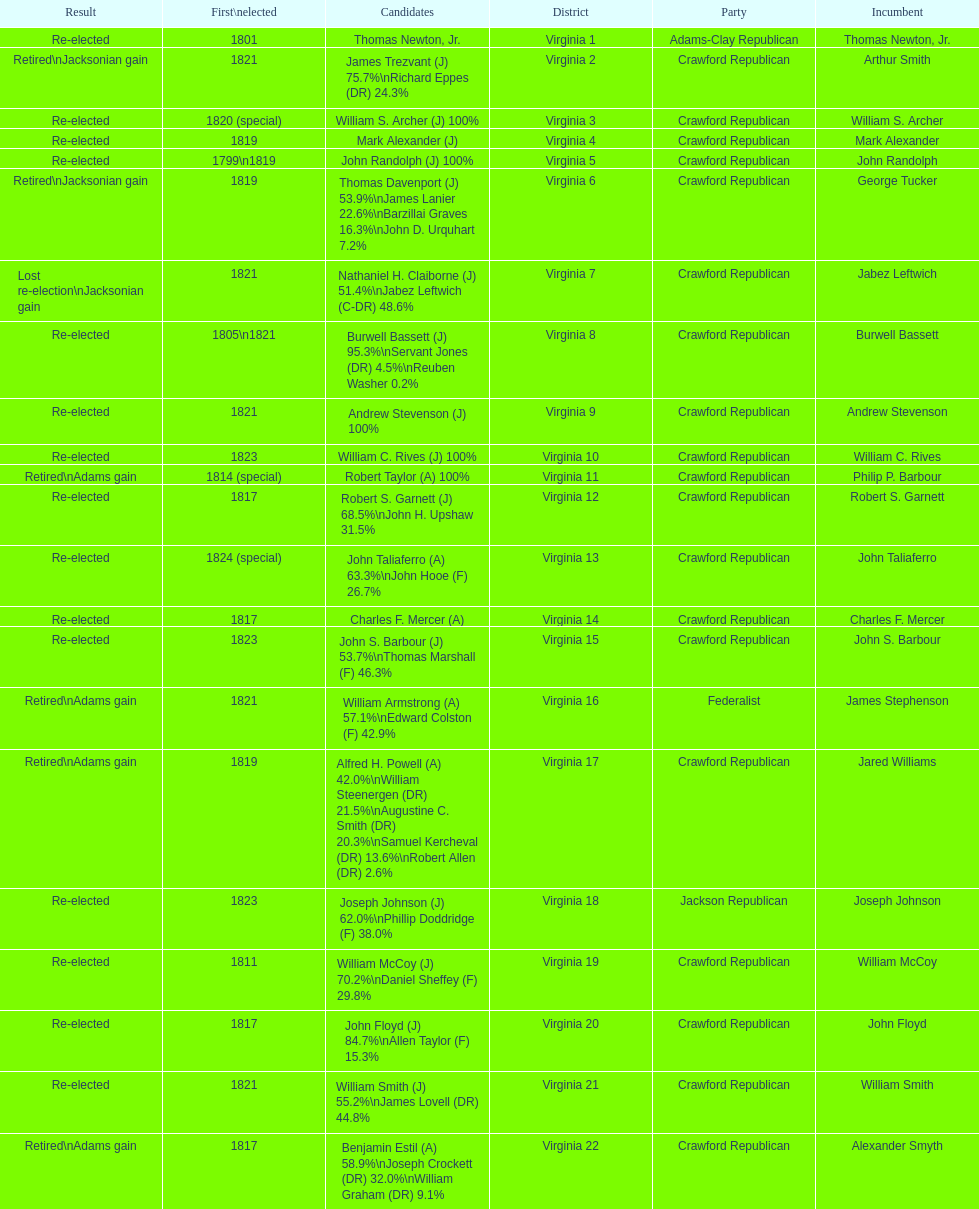Which jacksonian candidates got at least 76% of the vote in their races? Arthur Smith. Parse the table in full. {'header': ['Result', 'First\\nelected', 'Candidates', 'District', 'Party', 'Incumbent'], 'rows': [['Re-elected', '1801', 'Thomas Newton, Jr.', 'Virginia 1', 'Adams-Clay Republican', 'Thomas Newton, Jr.'], ['Retired\\nJacksonian gain', '1821', 'James Trezvant (J) 75.7%\\nRichard Eppes (DR) 24.3%', 'Virginia 2', 'Crawford Republican', 'Arthur Smith'], ['Re-elected', '1820 (special)', 'William S. Archer (J) 100%', 'Virginia 3', 'Crawford Republican', 'William S. Archer'], ['Re-elected', '1819', 'Mark Alexander (J)', 'Virginia 4', 'Crawford Republican', 'Mark Alexander'], ['Re-elected', '1799\\n1819', 'John Randolph (J) 100%', 'Virginia 5', 'Crawford Republican', 'John Randolph'], ['Retired\\nJacksonian gain', '1819', 'Thomas Davenport (J) 53.9%\\nJames Lanier 22.6%\\nBarzillai Graves 16.3%\\nJohn D. Urquhart 7.2%', 'Virginia 6', 'Crawford Republican', 'George Tucker'], ['Lost re-election\\nJacksonian gain', '1821', 'Nathaniel H. Claiborne (J) 51.4%\\nJabez Leftwich (C-DR) 48.6%', 'Virginia 7', 'Crawford Republican', 'Jabez Leftwich'], ['Re-elected', '1805\\n1821', 'Burwell Bassett (J) 95.3%\\nServant Jones (DR) 4.5%\\nReuben Washer 0.2%', 'Virginia 8', 'Crawford Republican', 'Burwell Bassett'], ['Re-elected', '1821', 'Andrew Stevenson (J) 100%', 'Virginia 9', 'Crawford Republican', 'Andrew Stevenson'], ['Re-elected', '1823', 'William C. Rives (J) 100%', 'Virginia 10', 'Crawford Republican', 'William C. Rives'], ['Retired\\nAdams gain', '1814 (special)', 'Robert Taylor (A) 100%', 'Virginia 11', 'Crawford Republican', 'Philip P. Barbour'], ['Re-elected', '1817', 'Robert S. Garnett (J) 68.5%\\nJohn H. Upshaw 31.5%', 'Virginia 12', 'Crawford Republican', 'Robert S. Garnett'], ['Re-elected', '1824 (special)', 'John Taliaferro (A) 63.3%\\nJohn Hooe (F) 26.7%', 'Virginia 13', 'Crawford Republican', 'John Taliaferro'], ['Re-elected', '1817', 'Charles F. Mercer (A)', 'Virginia 14', 'Crawford Republican', 'Charles F. Mercer'], ['Re-elected', '1823', 'John S. Barbour (J) 53.7%\\nThomas Marshall (F) 46.3%', 'Virginia 15', 'Crawford Republican', 'John S. Barbour'], ['Retired\\nAdams gain', '1821', 'William Armstrong (A) 57.1%\\nEdward Colston (F) 42.9%', 'Virginia 16', 'Federalist', 'James Stephenson'], ['Retired\\nAdams gain', '1819', 'Alfred H. Powell (A) 42.0%\\nWilliam Steenergen (DR) 21.5%\\nAugustine C. Smith (DR) 20.3%\\nSamuel Kercheval (DR) 13.6%\\nRobert Allen (DR) 2.6%', 'Virginia 17', 'Crawford Republican', 'Jared Williams'], ['Re-elected', '1823', 'Joseph Johnson (J) 62.0%\\nPhillip Doddridge (F) 38.0%', 'Virginia 18', 'Jackson Republican', 'Joseph Johnson'], ['Re-elected', '1811', 'William McCoy (J) 70.2%\\nDaniel Sheffey (F) 29.8%', 'Virginia 19', 'Crawford Republican', 'William McCoy'], ['Re-elected', '1817', 'John Floyd (J) 84.7%\\nAllen Taylor (F) 15.3%', 'Virginia 20', 'Crawford Republican', 'John Floyd'], ['Re-elected', '1821', 'William Smith (J) 55.2%\\nJames Lovell (DR) 44.8%', 'Virginia 21', 'Crawford Republican', 'William Smith'], ['Retired\\nAdams gain', '1817', 'Benjamin Estil (A) 58.9%\\nJoseph Crockett (DR) 32.0%\\nWilliam Graham (DR) 9.1%', 'Virginia 22', 'Crawford Republican', 'Alexander Smyth']]} 